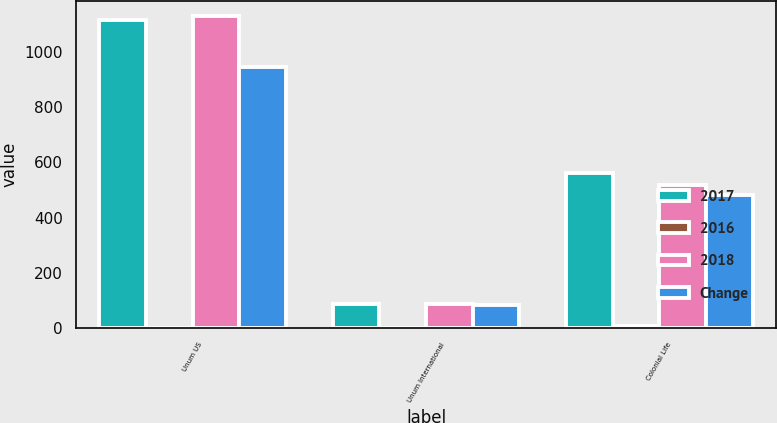Convert chart to OTSL. <chart><loc_0><loc_0><loc_500><loc_500><stacked_bar_chart><ecel><fcel>Unum US<fcel>Unum International<fcel>Colonial Life<nl><fcel>2017<fcel>1114.6<fcel>87<fcel>561.3<nl><fcel>2016<fcel>1.3<fcel>1.3<fcel>8<nl><fcel>2018<fcel>1129<fcel>85.9<fcel>519.7<nl><fcel>Change<fcel>943.8<fcel>84.5<fcel>483.6<nl></chart> 